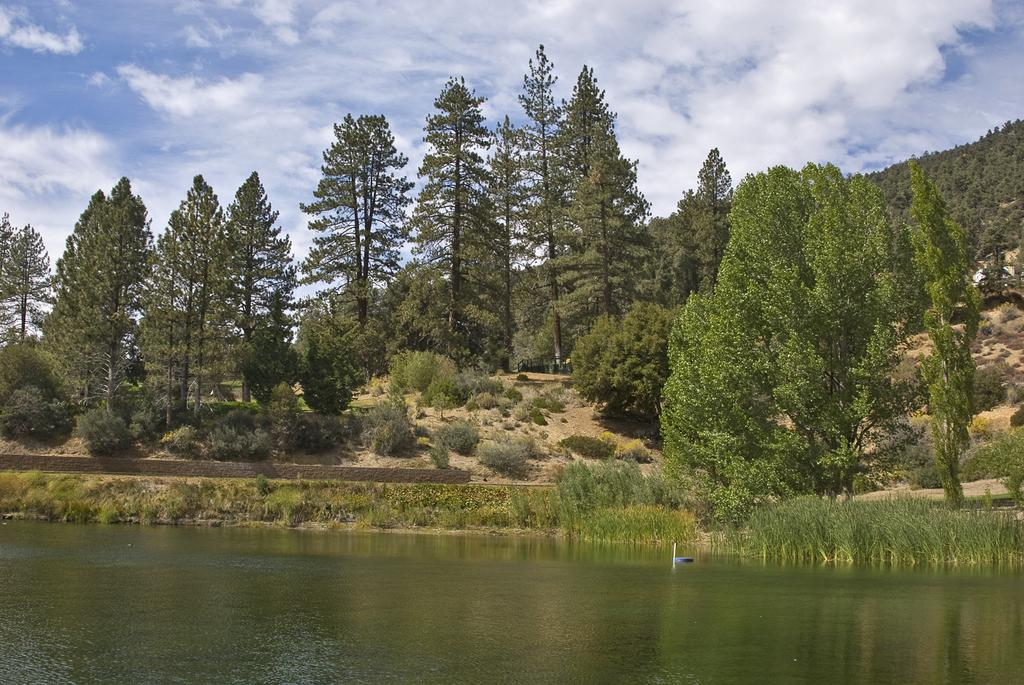What type of natural feature can be seen in the image? There is a river in the image. What type of vegetation is present in the image? There are trees and plants in the image. What part of the natural environment is visible in the image? The sky is visible in the image. What type of comfort does the dad provide to the banana in the image? There is no dad or banana present in the image, so this question cannot be answered. 